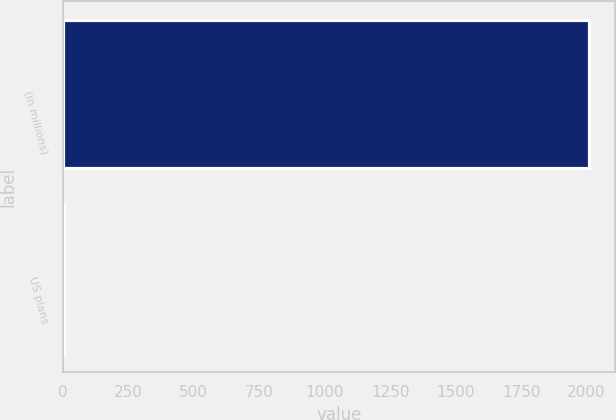<chart> <loc_0><loc_0><loc_500><loc_500><bar_chart><fcel>(in millions)<fcel>US plans<nl><fcel>2009<fcel>4<nl></chart> 